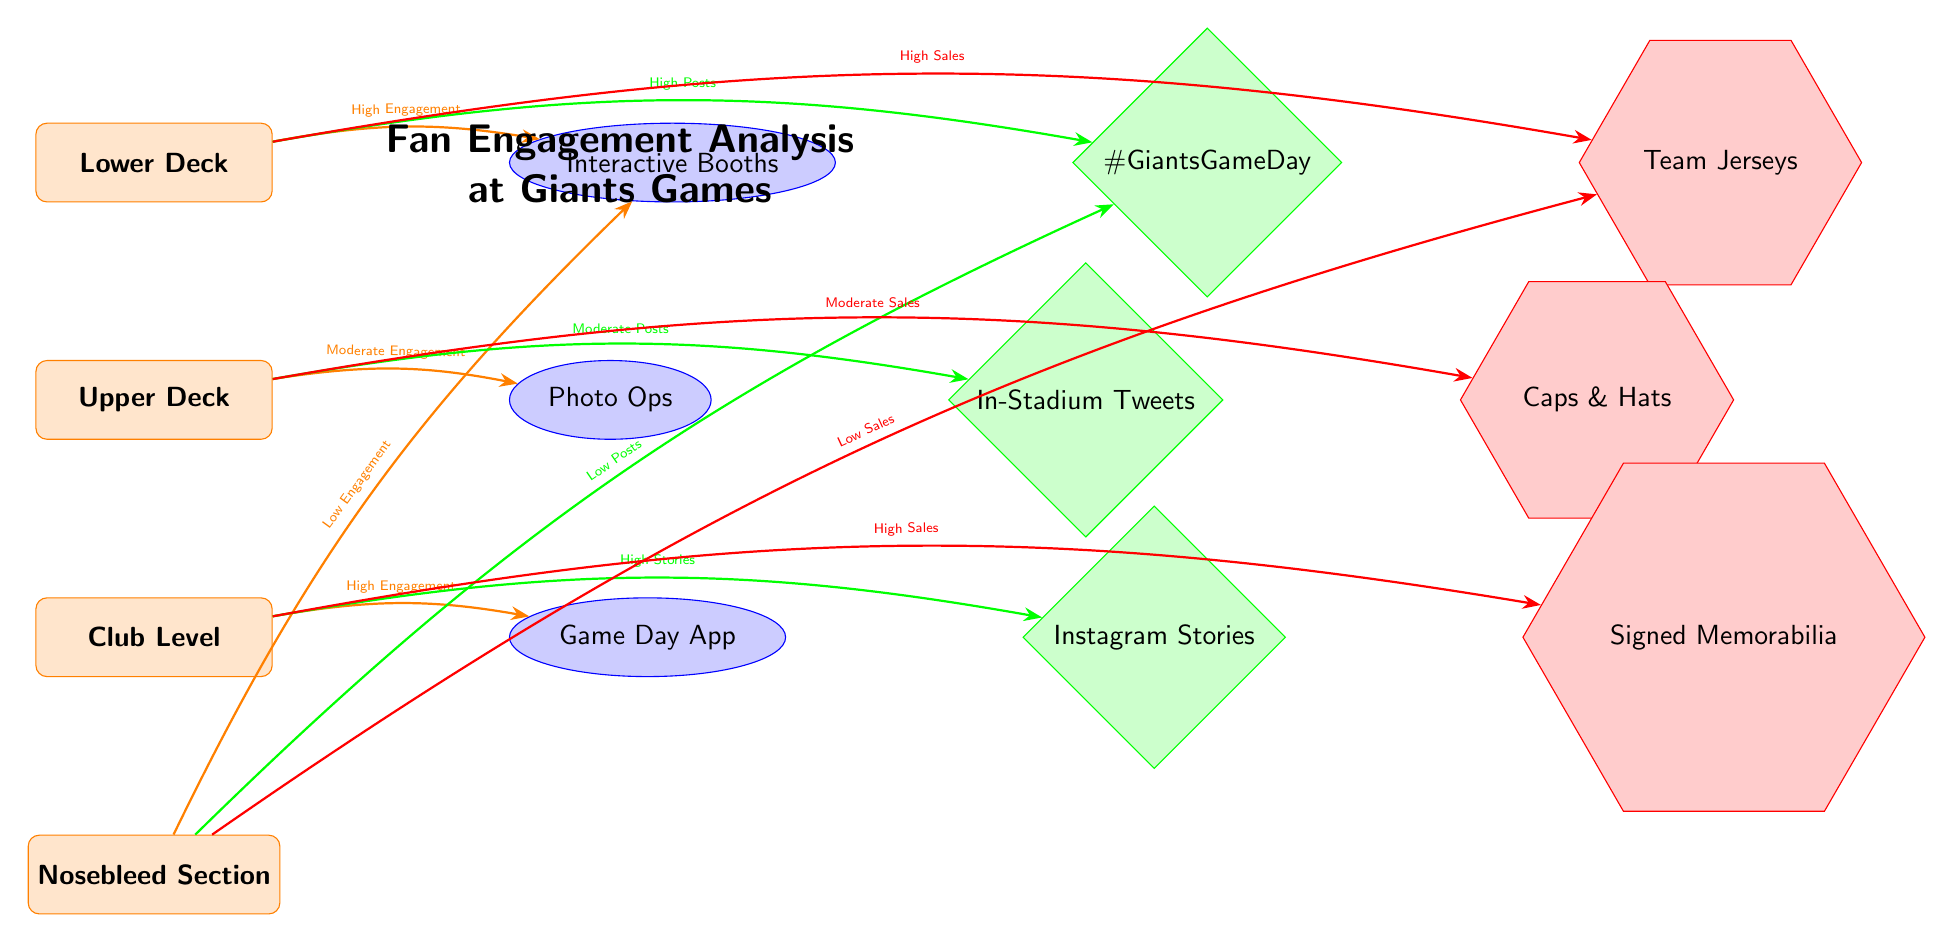What's the highest level of engagement in the Lower Deck? The diagram shows that the connection from the Lower Deck to the Interactive Booths indicates "High Engagement." This is the only engagement level mentioned for that zone.
Answer: High Engagement Which zone is associated with the Game Day App? The diagram connects the Club Level to the Game Day App, indicating that this activity is specifically linked to that zone.
Answer: Club Level What type of merchandise has high sales in the Lower Deck? The diagram illustrates a connection from the Lower Deck to Team Jerseys, which states "High Sales." This is the only merchandise listed for high sales in that zone.
Answer: Team Jerseys Which stadium zone has low engagement? The Nosebleed Section is noted as having low engagement, as indicated by the connection to Interactive Booths stating "Low Engagement."
Answer: Nosebleed Section What activity is linked to high social media posts in the Lower Deck? The diagram connects the Lower Deck to the hashtag #GiantsGameDay, which identifies it as having "High Posts" in social media engagement.
Answer: #GiantsGameDay Which merchandise is related to moderate sales in the Upper Deck? The connection from the Upper Deck to Caps & Hats states "Moderate Sales," making it clear which type of merchandise corresponds with moderate sales in that zone.
Answer: Caps & Hats What is the relationship between the Club Level and Instagram Stories? The Club Level is linked to Instagram Stories with a connection indicating "High Stories," representing high engagement with that type of social media interaction.
Answer: High Stories How many types of activities are listed in the diagram? There are three distinct activities mentioned: Interactive Booths, Photo Ops, and Game Day App. Counting each of these gives a total of three types of activities.
Answer: 3 Which section shows low posts in social media? The Nosebleed Section is connected to the hashtag #GiantsGameDay, which reflects "Low Posts," confirming it as the section with low social media activity.
Answer: Nosebleed Section 